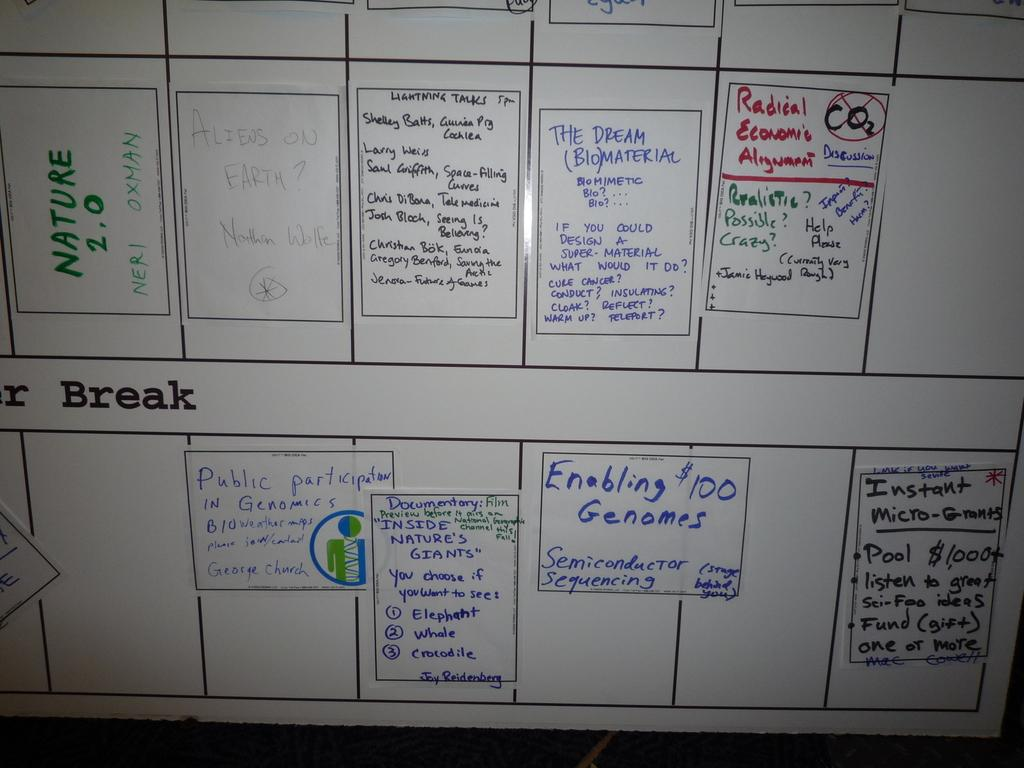<image>
Summarize the visual content of the image. A whiteboard that has the word break on it 